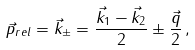Convert formula to latex. <formula><loc_0><loc_0><loc_500><loc_500>\vec { p } _ { r e l } = \vec { k } _ { \pm } = \frac { \vec { k } _ { 1 } - \vec { k } _ { 2 } } { 2 } \pm \frac { \vec { q } } { 2 } \, ,</formula> 